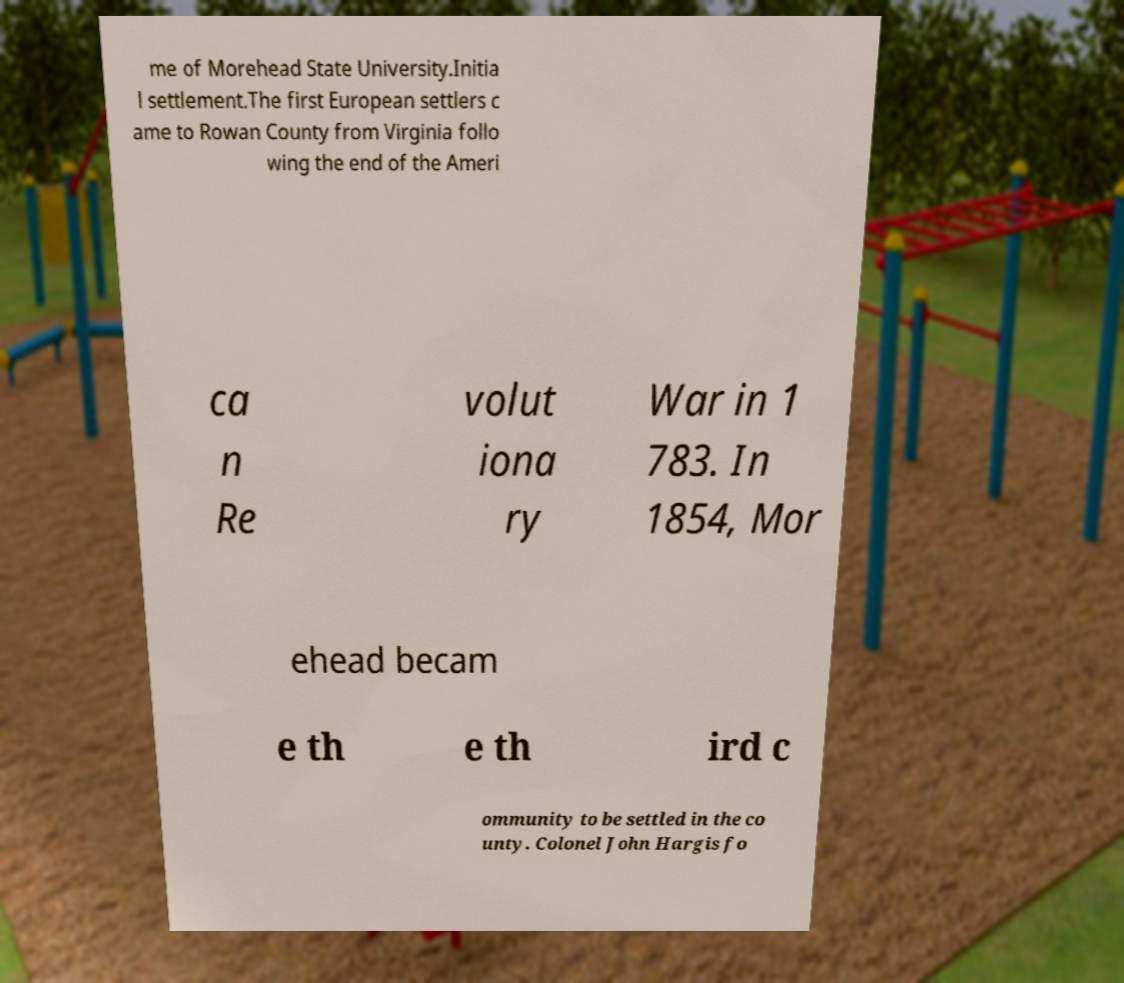What messages or text are displayed in this image? I need them in a readable, typed format. me of Morehead State University.Initia l settlement.The first European settlers c ame to Rowan County from Virginia follo wing the end of the Ameri ca n Re volut iona ry War in 1 783. In 1854, Mor ehead becam e th e th ird c ommunity to be settled in the co unty. Colonel John Hargis fo 